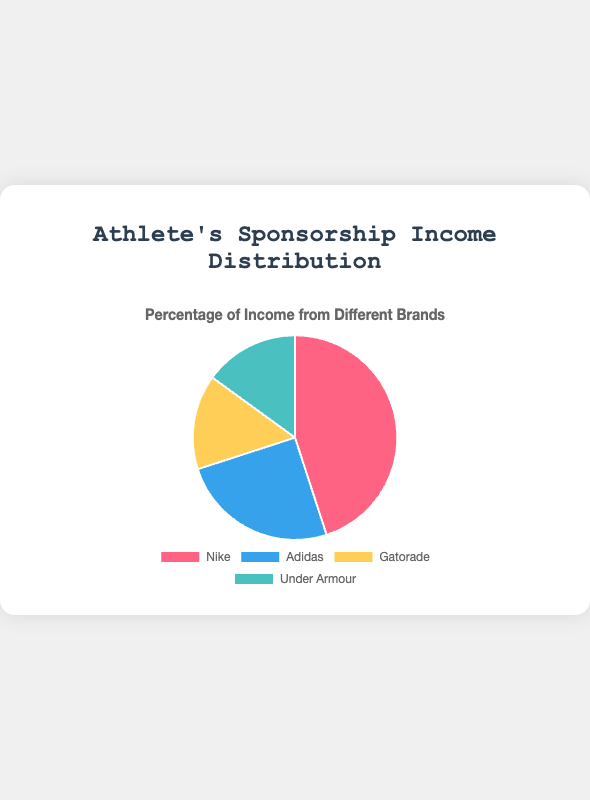What percentage of the athlete's income comes from Nike? Nike contributes 45% to the athlete's income, as can be directly read from the pie chart.
Answer: 45% Which brand contributes more to the athlete's income, Adidas or Under Armour? From the pie chart, Adidas contributes 25%, and Under Armour contributes 15%. Since 25% is greater than 15%, Adidas contributes more.
Answer: Adidas What is the combined percentage of income from Gatorade and Under Armour? Adding the percentages from the pie chart: Gatorade (15%) and Under Armour (15%) gives 15% + 15% = 30%.
Answer: 30% Which brand has the second highest percentage of the athlete's sponsorship income? The percentages are: Nike (45%), Adidas (25%), Gatorade (15%), and Under Armour (15%). Adidas, with 25%, is the second highest.
Answer: Adidas Is the combined income from Gatorade and Under Armour greater than that from Adidas? Gatorade (15%) + Under Armour (15%) = 30%. Adidas contributes 25%. Since 30% is greater than 25%, the combined income from Gatorade and Under Armour is greater.
Answer: Yes How much more does Nike contribute to the athlete's income compared to Gatorade? Nike contributes 45%, and Gatorade contributes 15%. The difference is 45% - 15% = 30%.
Answer: 30% What proportion of the total sponsorship income comes from brands other than Nike? The total for Adidas, Gatorade, and Under Armour is 25% + 15% + 15% = 55%.
Answer: 55% What is the average percentage of income from all four brands? Summing the percentages: 45% (Nike) + 25% (Adidas) + 15% (Gatorade) + 15% (Under Armour) gives a total of 100%. The average is 100% / 4 = 25%.
Answer: 25% Which brand is represented by the light blue color? By referring to the pie chart, the brand that aligns with the light blue color is Under Armour.
Answer: Under Armour If you were to only consider the brands with less than 20% contribution, what is their total percentage? Both Gatorade and Under Armour contribute 15% each. Adding these gives 15% + 15% = 30%.
Answer: 30% 